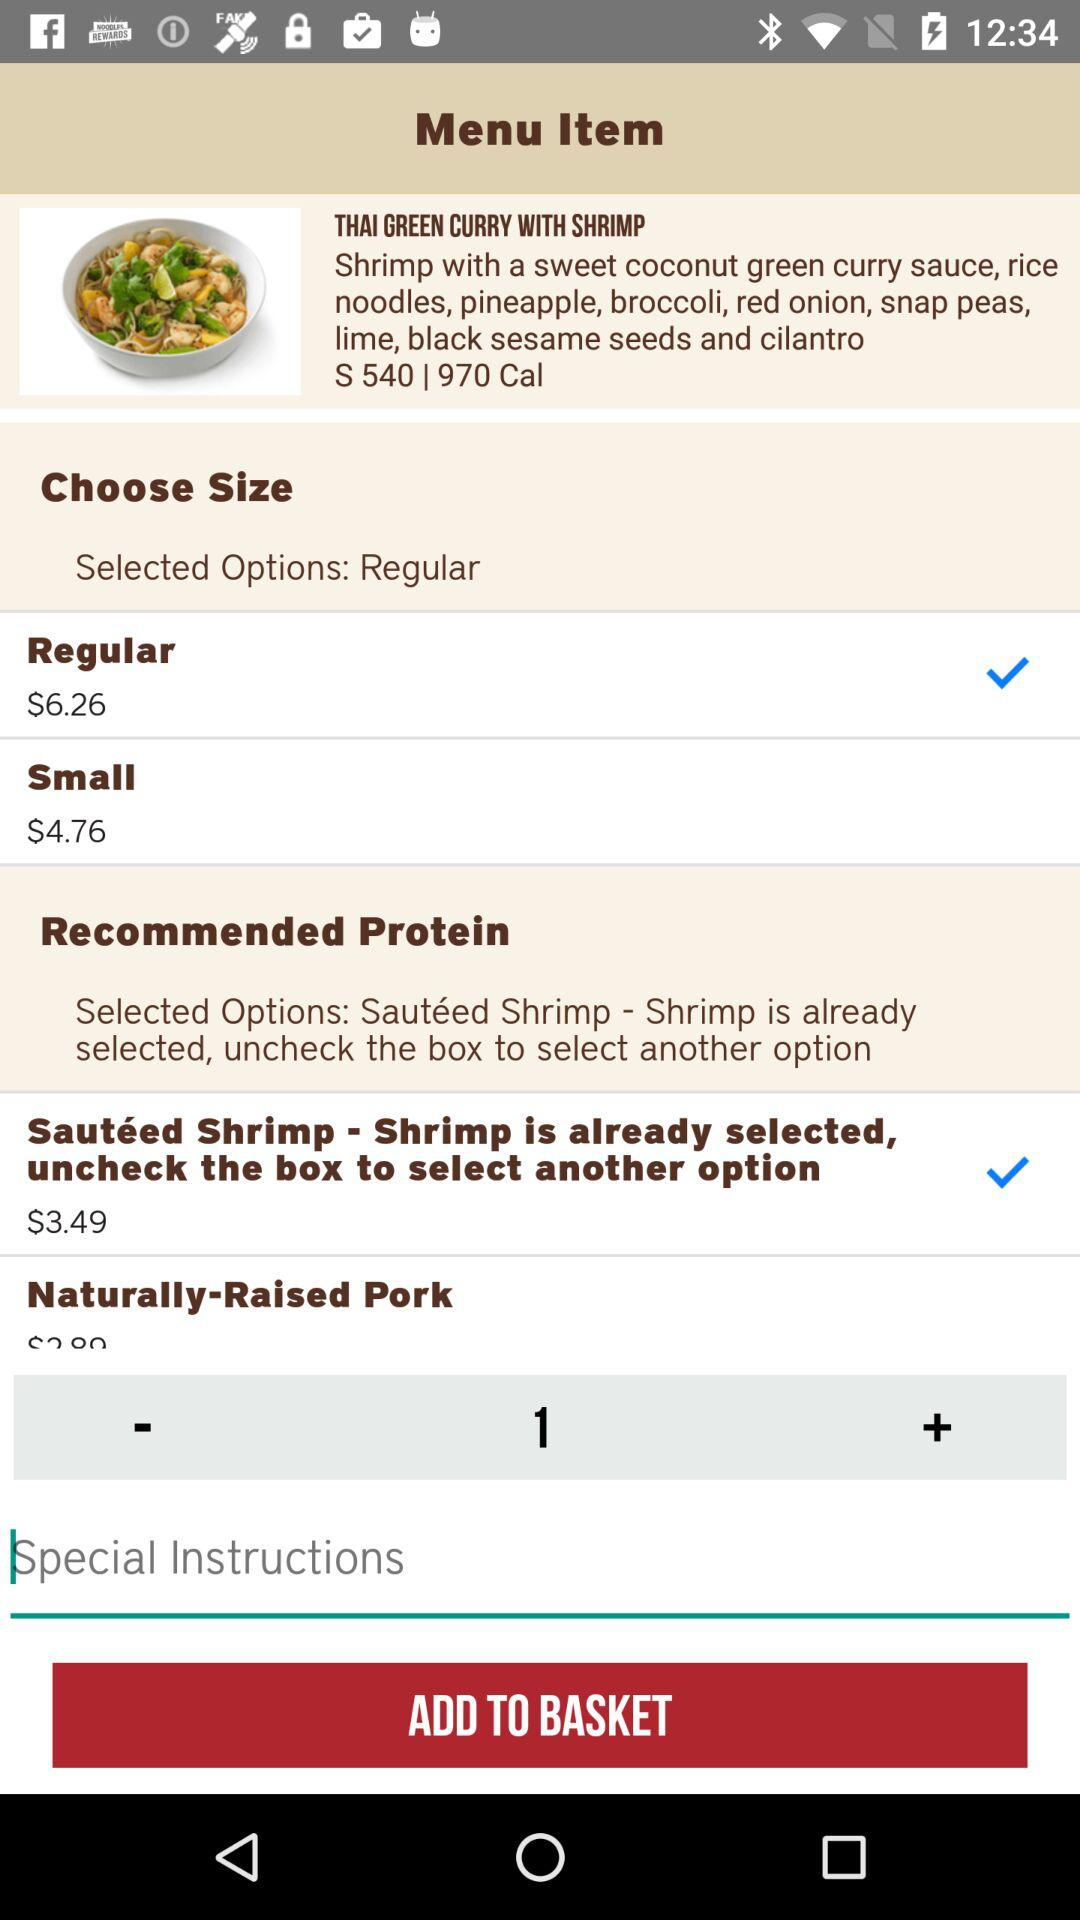How many different proteins are available for the Thai Green Curry with Shrimp?
Answer the question using a single word or phrase. 2 